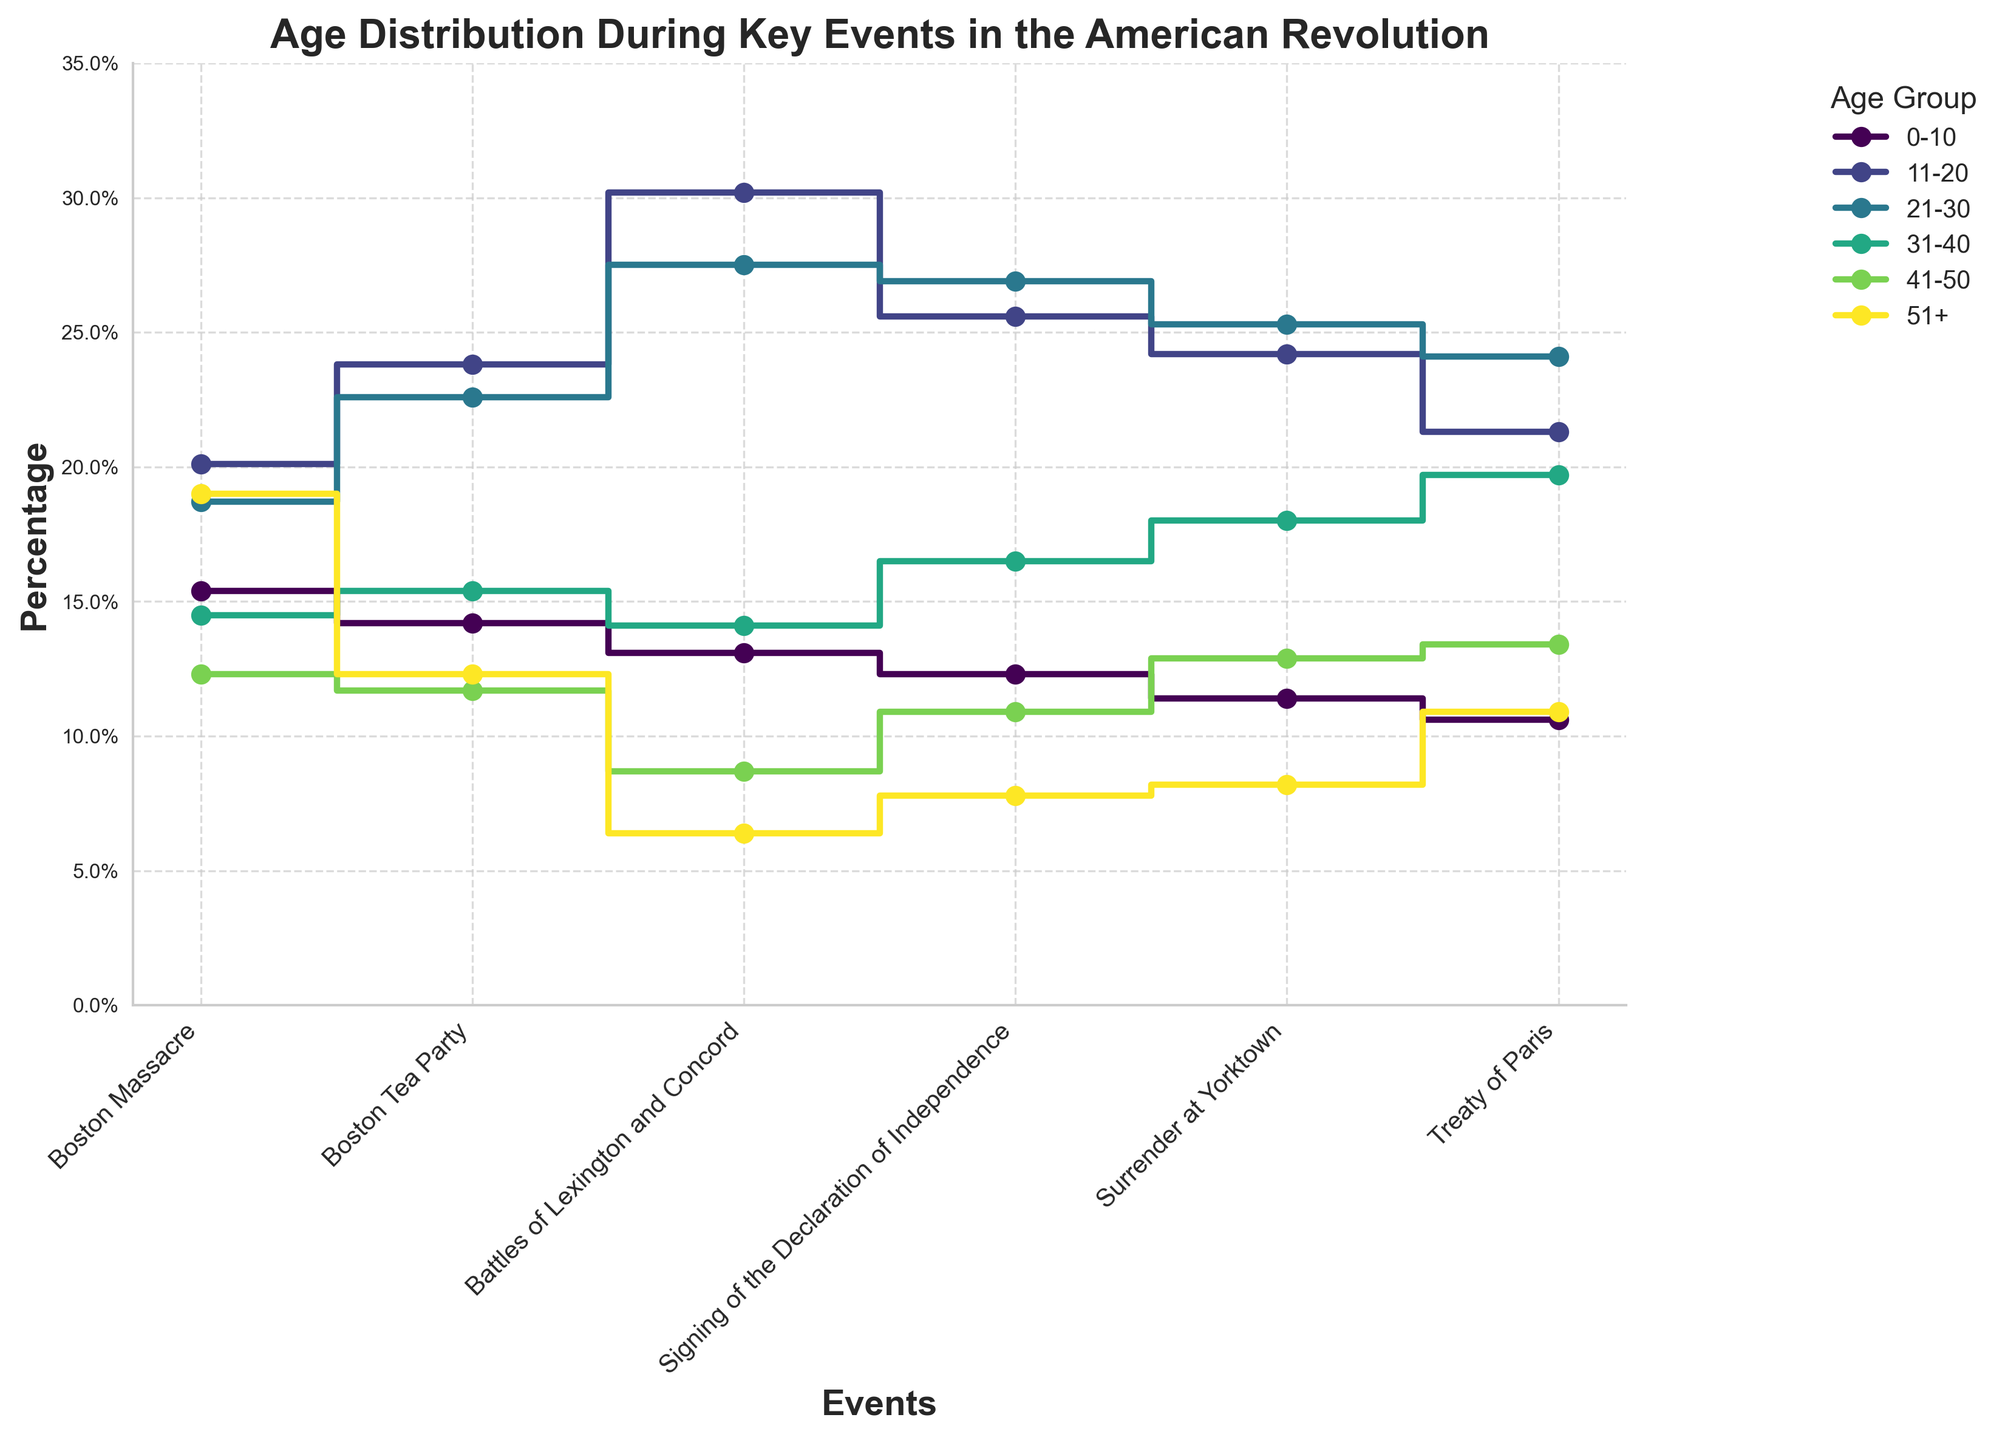What event shows the highest percentage for the age group 11-20? From the plot, follow the line representing the age group 11-20. The highest percentage is at the "Battles of Lexington and Concord" event.
Answer: Battles of Lexington and Concord How does the percentage for the age group 51+ change from the Boston Massacre to the Treaty of Paris? Observe the starting percentage for 51+ at the Boston Massacre (19.0%) and at the end point of the Treaty of Paris (10.9%). Subtract the ending value from the starting value.
Answer: It decreases by 8.1% Which age group shows the lowest percentage during the Signing of the Declaration of Independence? Identify the bars representing percentages at each age group during the Signing of the Declaration of Independence. The lowest bar belongs to the age group 51+, which is 7.8%.
Answer: 51+ Is there an event where the age group 21-30 has consistently higher percentages than other events? Check the trajectory of the 21-30 age group across all events and compare it with the other age groups. The "Signing of the Declaration of Independence" and "Surrender at Yorktown" events show higher consistent percentages, with the Signing being slightly higher.
Answer: Yes, Signing of the Declaration of Independence Do the age groups 31-40 and 41-50 ever have the same percentage at any event? Track the lines for age groups 31-40 and 41-50 across all events. They do not intersect or touch each other at any point.
Answer: No Which event had the overall lowest percentage recorded, and which age group does it belong to? Look at the smallest bars across all age groups and events. The "Battles of Lexington and Concord" event for the age group 51+ has the lowest percentage recorded at 6.4%.
Answer: Battles of Lexington and Concord, age group 51+ Between the events "Boston Massacre" and "Battles of Lexington and Concord," how did the percentage for age group 11-20 change? Calculate the difference in percentages for age group 11-20 between the two events. For Boston Massacre it is 20.1% and for Battles of Lexington and Concord it is 30.2%. Subtract the earlier value from the later one.
Answer: Increased by 10.1% What is the average percentage for the age group 21-30 across all events? Sum the percentages of the age group 21-30 for all events (18.7 + 22.6 + 27.5 + 26.9 + 25.3 + 24.1) and then divide by the number of events, which is 6.
Answer: 24.2% Between which consecutive events did the age group 0-10 see the greatest drop in percentage? Calculate the difference between consecutive events for the age group 0-10. The highest drop is from the Boston Massacre (15.4%) to Boston Tea Party (14.2%), dropping by 1.2%. Other events have even lesser drops.
Answer: Boston Massacre to Boston Tea Party For the Surrender at Yorktown, which age group has the most similar percentage to the age group 41-50? Compare percentages in the Surrender at Yorktown event for all age groups to the 41-50 age group (12.9%). The closest percentage is the age group 51+ with 8.2%.
Answer: Age group 51+ 